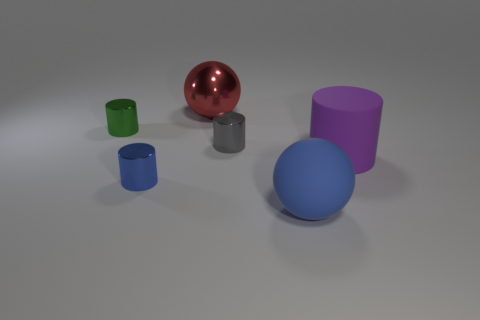Add 1 rubber things. How many objects exist? 7 Subtract all cylinders. How many objects are left? 2 Subtract 0 yellow cylinders. How many objects are left? 6 Subtract all large purple things. Subtract all purple rubber cylinders. How many objects are left? 4 Add 5 large red metallic objects. How many large red metallic objects are left? 6 Add 6 big gray things. How many big gray things exist? 6 